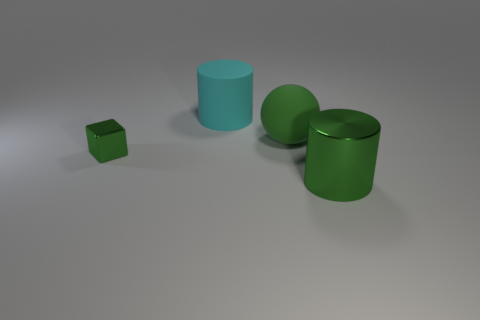Add 3 tiny purple matte cylinders. How many objects exist? 7 Subtract all blocks. How many objects are left? 3 Add 3 cyan objects. How many cyan objects exist? 4 Subtract 0 red blocks. How many objects are left? 4 Subtract all tiny green blocks. Subtract all small green objects. How many objects are left? 2 Add 4 large rubber cylinders. How many large rubber cylinders are left? 5 